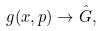<formula> <loc_0><loc_0><loc_500><loc_500>g ( x , p ) \rightarrow \hat { G } ,</formula> 